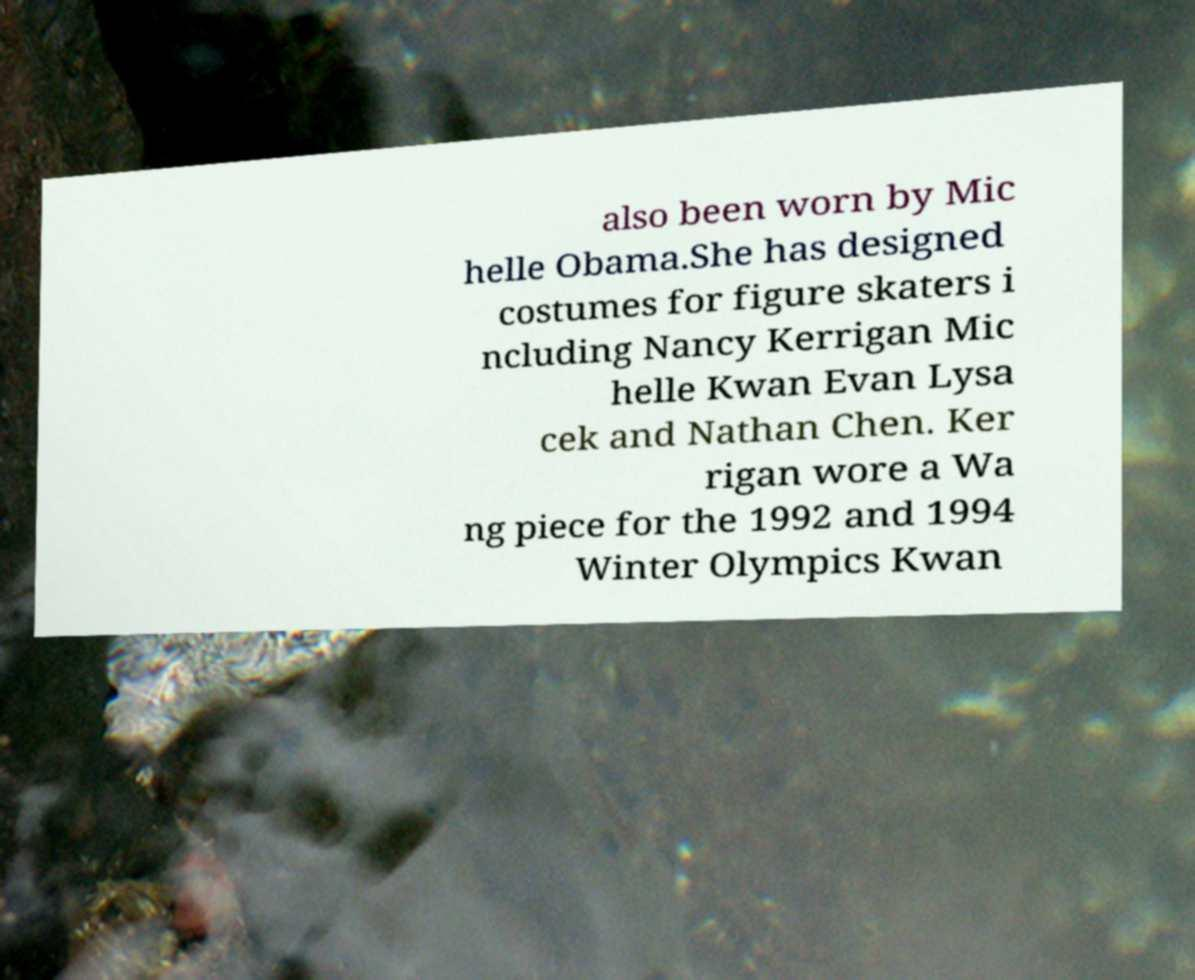I need the written content from this picture converted into text. Can you do that? also been worn by Mic helle Obama.She has designed costumes for figure skaters i ncluding Nancy Kerrigan Mic helle Kwan Evan Lysa cek and Nathan Chen. Ker rigan wore a Wa ng piece for the 1992 and 1994 Winter Olympics Kwan 